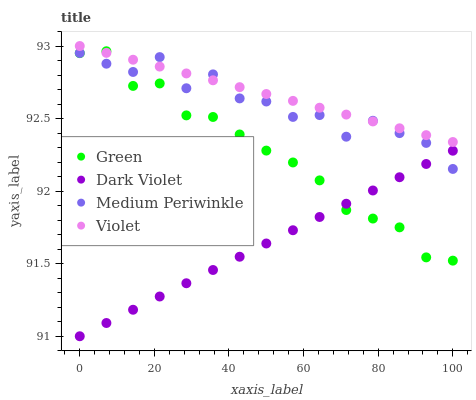Does Dark Violet have the minimum area under the curve?
Answer yes or no. Yes. Does Violet have the maximum area under the curve?
Answer yes or no. Yes. Does Green have the minimum area under the curve?
Answer yes or no. No. Does Green have the maximum area under the curve?
Answer yes or no. No. Is Dark Violet the smoothest?
Answer yes or no. Yes. Is Medium Periwinkle the roughest?
Answer yes or no. Yes. Is Green the smoothest?
Answer yes or no. No. Is Green the roughest?
Answer yes or no. No. Does Dark Violet have the lowest value?
Answer yes or no. Yes. Does Green have the lowest value?
Answer yes or no. No. Does Violet have the highest value?
Answer yes or no. Yes. Does Green have the highest value?
Answer yes or no. No. Is Dark Violet less than Violet?
Answer yes or no. Yes. Is Violet greater than Dark Violet?
Answer yes or no. Yes. Does Dark Violet intersect Medium Periwinkle?
Answer yes or no. Yes. Is Dark Violet less than Medium Periwinkle?
Answer yes or no. No. Is Dark Violet greater than Medium Periwinkle?
Answer yes or no. No. Does Dark Violet intersect Violet?
Answer yes or no. No. 